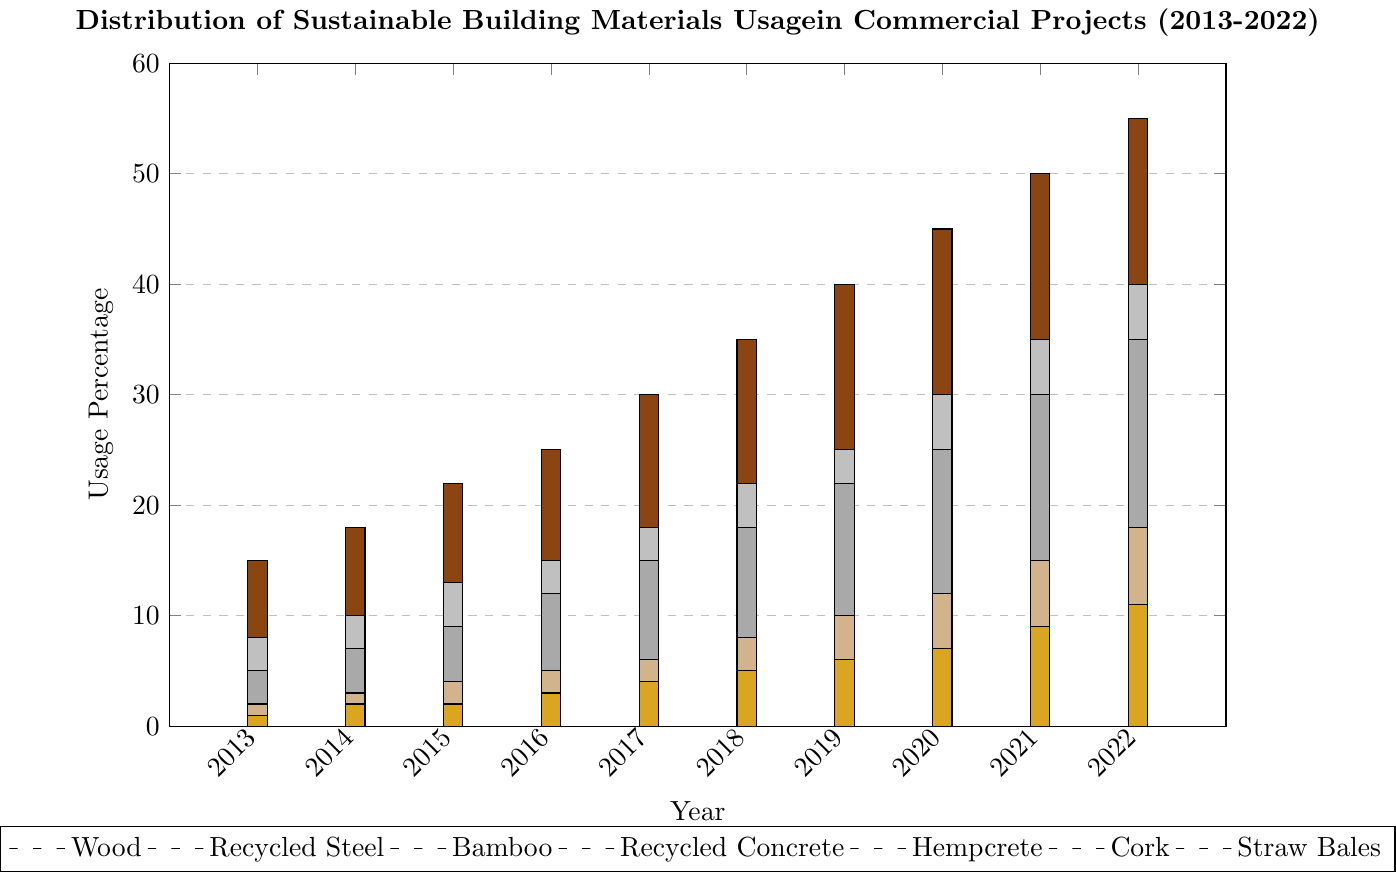Which material had the highest usage percentage in 2022? The highest bar in 2022 is for Wood.
Answer: Wood Between 2015 and 2020, which sustainable building material saw the greatest increase in usage? Comparing the heights of the bars from 2015 to 2020 for each material, Wood increased from 22% to 45%, which is the greatest increase.
Answer: Wood By how many percentage points did the usage of Recycled Concrete grow from 2013 to 2022? The bar for Recycled Concrete in 2013 is at 5%, and in 2022 it is at 35%, so the growth is 35% - 5% = 30 percentage points.
Answer: 30 Which two materials had an equal usage percentage in 2014? Looking at the 2014 bars, both Straw Bales and Hempcrete are at 2%.
Answer: Straw Bales and Hempcrete What is the overall trend in the usage of Hempcrete from 2013 to 2022? The bars for Hempcrete show a steady increase from 1% in 2013 to 17% in 2022.
Answer: Increasing trend How many years did it take for Bamboo usage to increase from 3% to 15%? Bamboo usage was 3% in 2013 and reached 15% in 2019; counting the years from 2013 to 2019 gives 6 years.
Answer: 6 years In which year did Cork usage surpass 10%? The bar for Cork reaches above 10% in 2019.
Answer: 2019 By how many percentage points did Recycled Steel usage increase from 2018 to 2020? The bar for Recycled Steel in 2018 is at 22%, and in 2020 it is at 30%, so the increase is 30% - 22% = 8 percentage points.
Answer: 8 What is the average usage percentage of Wood over the years 2013 to 2022? Summing the usage percentages for Wood from 2013 to 2022: 15 + 18 + 22 + 25 + 30 + 35 + 40 + 45 + 50 + 55 = 335. There are 10 years, so the average is 335 / 10 = 33.5%
Answer: 33.5% Comparing 2017 and 2022, by how many percentage points has the usage of Straw Bales increased? From 2017 to 2022, Straw Bales usage increased from 4% to 11%, so the increase is 11% - 4% = 7 percentage points.
Answer: 7 